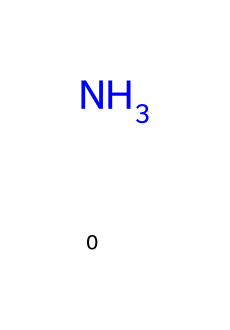What is the molecular formula for ammonia? The chemical is represented by the SMILES notation "N," which indicates one nitrogen atom and three hydrogen atoms (H3N). This corresponds to the molecular formula NH3 for ammonia.
Answer: NH3 How many hydrogen atoms are present in this compound? The SMILES representation shows that ammonia (N) is bonded to three hydrogen atoms, indicating the presence of three hydrogen atoms.
Answer: 3 What type of refrigerant is ammonia categorized as? Ammonia is classified as a natural refrigerant due to its occurrence in nature and minimal environmental impact compared to synthetic refrigerants.
Answer: natural What is the primary environmental concern associated with ammonia refrigerants? The main environmental issue involves toxicity and potential harm to ecosystems if released into the environment, although it does not contribute to ozone depletion.
Answer: toxicity What is the common application of ammonia as a refrigerant? Ammonia is extensively used in industrial refrigeration systems due to its high efficiency and low environmental impact compared to HFCs (hydrofluorocarbons).
Answer: industrial refrigeration Is ammonia considered a sustainable refrigerant? Yes, ammonia is often regarded as a sustainable refrigerant because it has no global warming potential (GWP) and is naturally occurring, making it a preferred choice for environmentally conscious applications.
Answer: yes 